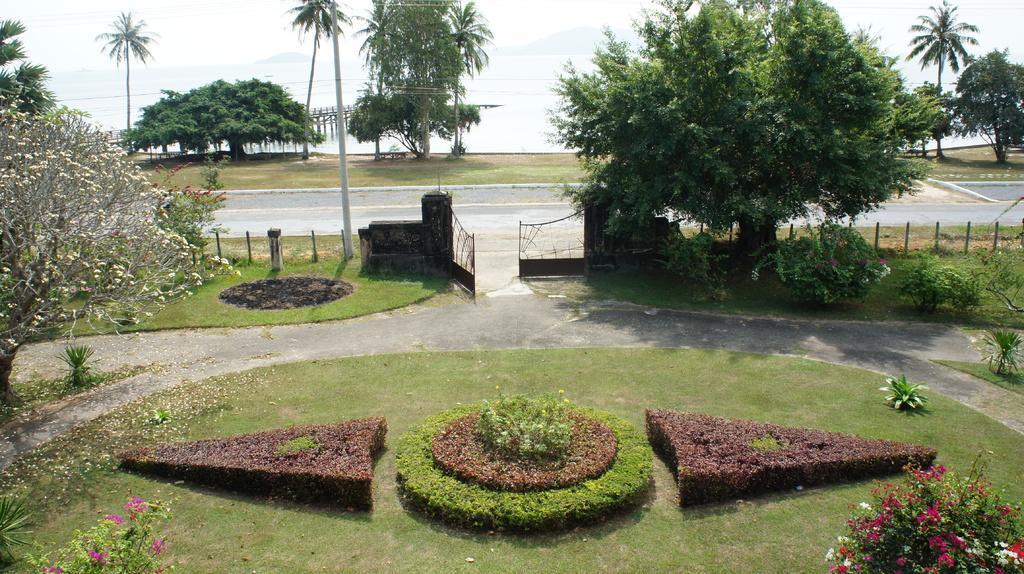Can you describe this image briefly? In this image there are trees. At the bottom there are plants and bushes. We can see flowers. There is a gate and we can see a fence. In the background there is water, hills and sky. We can see a pole. 